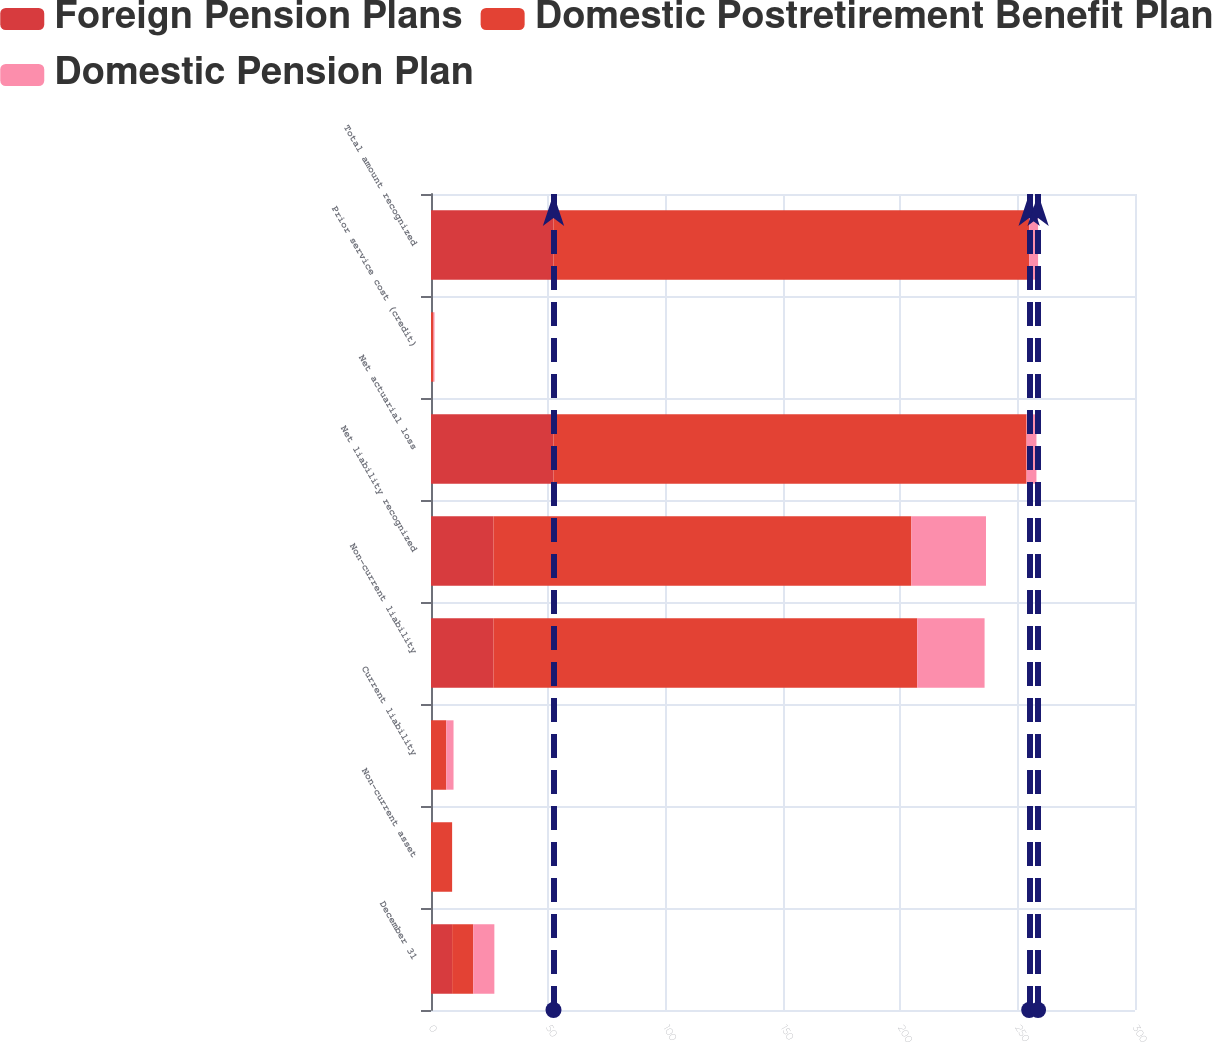Convert chart to OTSL. <chart><loc_0><loc_0><loc_500><loc_500><stacked_bar_chart><ecel><fcel>December 31<fcel>Non-current asset<fcel>Current liability<fcel>Non-current liability<fcel>Net liability recognized<fcel>Net actuarial loss<fcel>Prior service cost (credit)<fcel>Total amount recognized<nl><fcel>Foreign Pension Plans<fcel>9<fcel>0<fcel>0<fcel>26.6<fcel>26.6<fcel>52.2<fcel>0<fcel>52.2<nl><fcel>Domestic Postretirement Benefit Plan<fcel>9<fcel>9<fcel>6.5<fcel>180.6<fcel>178.1<fcel>201.6<fcel>1.1<fcel>202.7<nl><fcel>Domestic Pension Plan<fcel>9<fcel>0<fcel>3.1<fcel>28.7<fcel>31.8<fcel>4.2<fcel>0.4<fcel>3.8<nl></chart> 